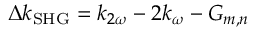<formula> <loc_0><loc_0><loc_500><loc_500>\Delta k _ { S H G } = k _ { 2 \omega } - 2 k _ { \omega } - G _ { m , n }</formula> 